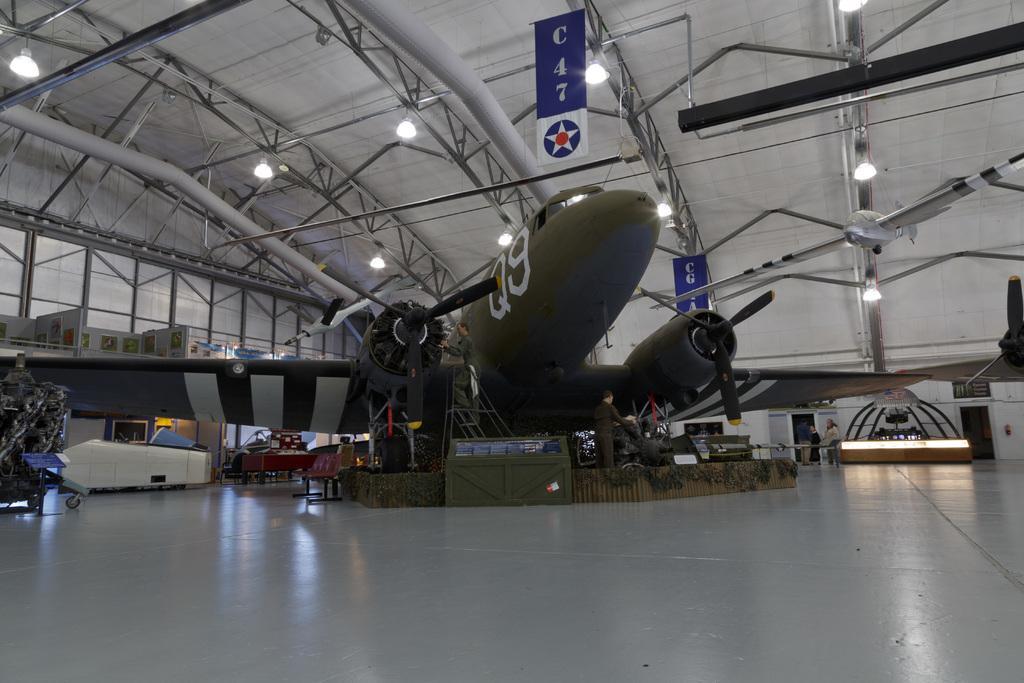What is the plane number of the green plane?
Your response must be concise. Q9. What space in the hangar does this plane occupy?
Offer a very short reply. C47. What letter-number designation was given to this airplane?
Your answer should be very brief. Q9. What is written on the banner above the plane?
Offer a terse response. C47. 